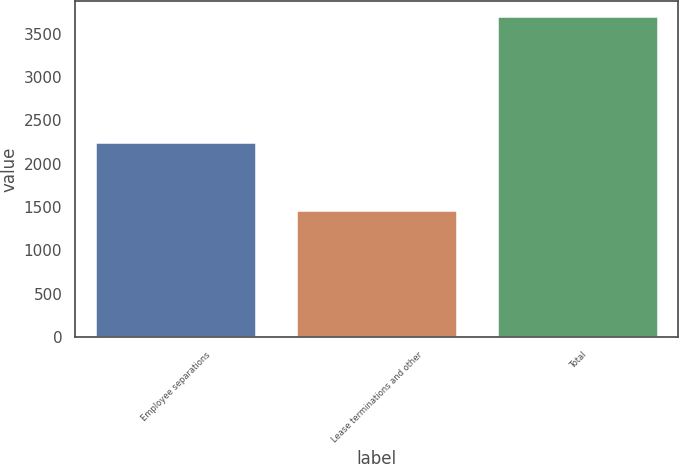Convert chart to OTSL. <chart><loc_0><loc_0><loc_500><loc_500><bar_chart><fcel>Employee separations<fcel>Lease terminations and other<fcel>Total<nl><fcel>2239<fcel>1450<fcel>3689<nl></chart> 